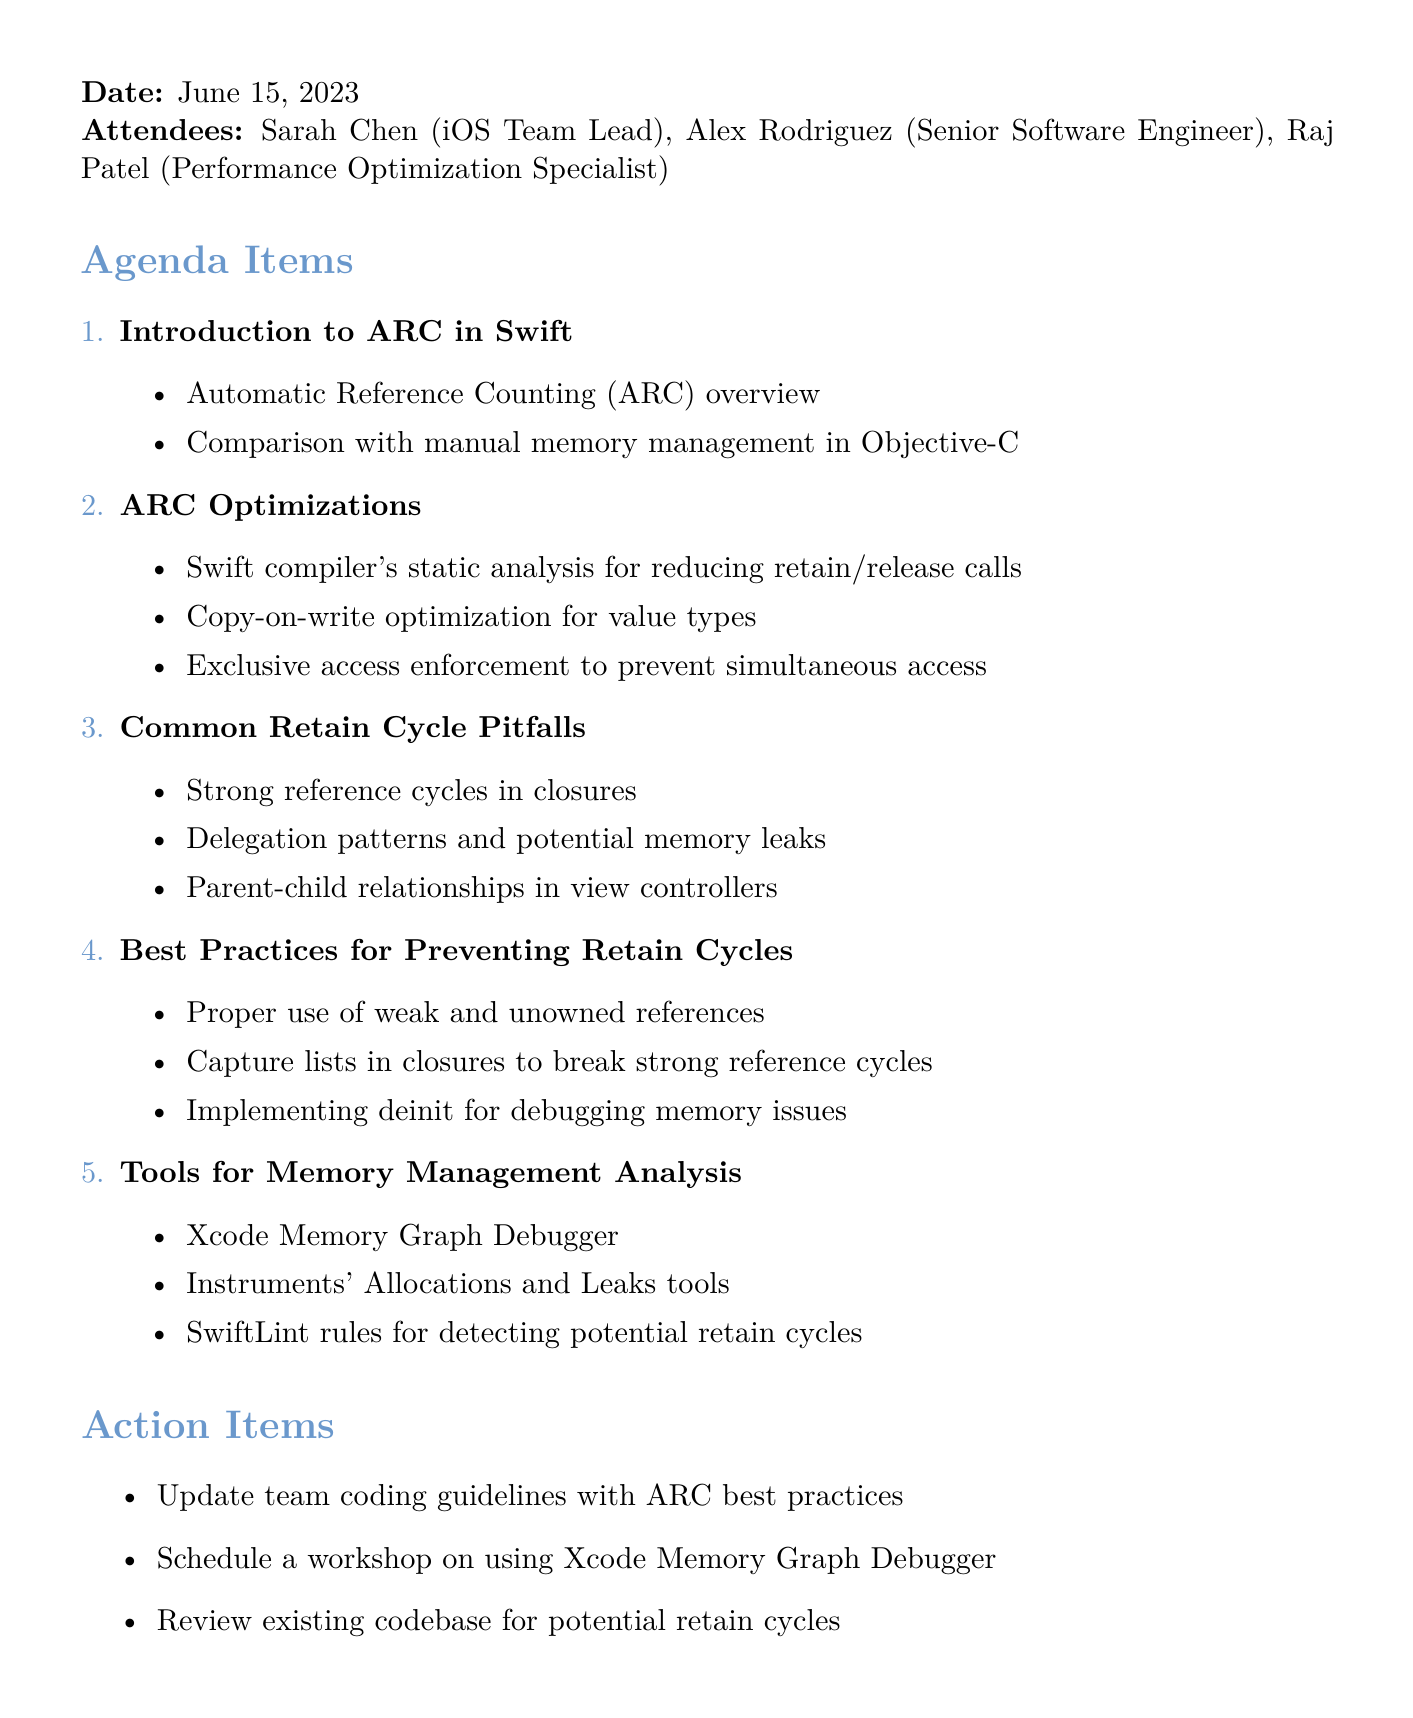What is the meeting title? The meeting title is explicitly mentioned at the beginning of the document.
Answer: Swift Memory Management: ARC Optimizations and Retain Cycle Prevention Who is the iOS Team Lead? The document lists attendees with their roles, and Sarah Chen is identified as the team lead.
Answer: Sarah Chen What date was the meeting held? The date of the meeting is provided clearly in the document.
Answer: June 15, 2023 How many agenda items are there? The number of agenda items is derived from the list provided in the document.
Answer: Six What is one of the ARC optimizations mentioned? The document includes several points under the ARC optimizations section.
Answer: Copy-on-write optimization for value types Which tool is suggested for memory management analysis? Tools for memory management analysis are listed in the document.
Answer: Xcode Memory Graph Debugger What is a common retain cycle pitfall? The document provides examples of common retain cycle pitfalls.
Answer: Strong reference cycles in closures What is one best practice for preventing retain cycles? Best practices are listed in the document, indicating effective strategies.
Answer: Proper use of weak and unowned references What is one action item listed in the document? The action items are specifically outlined in the meeting minutes.
Answer: Update team coding guidelines with ARC best practices 